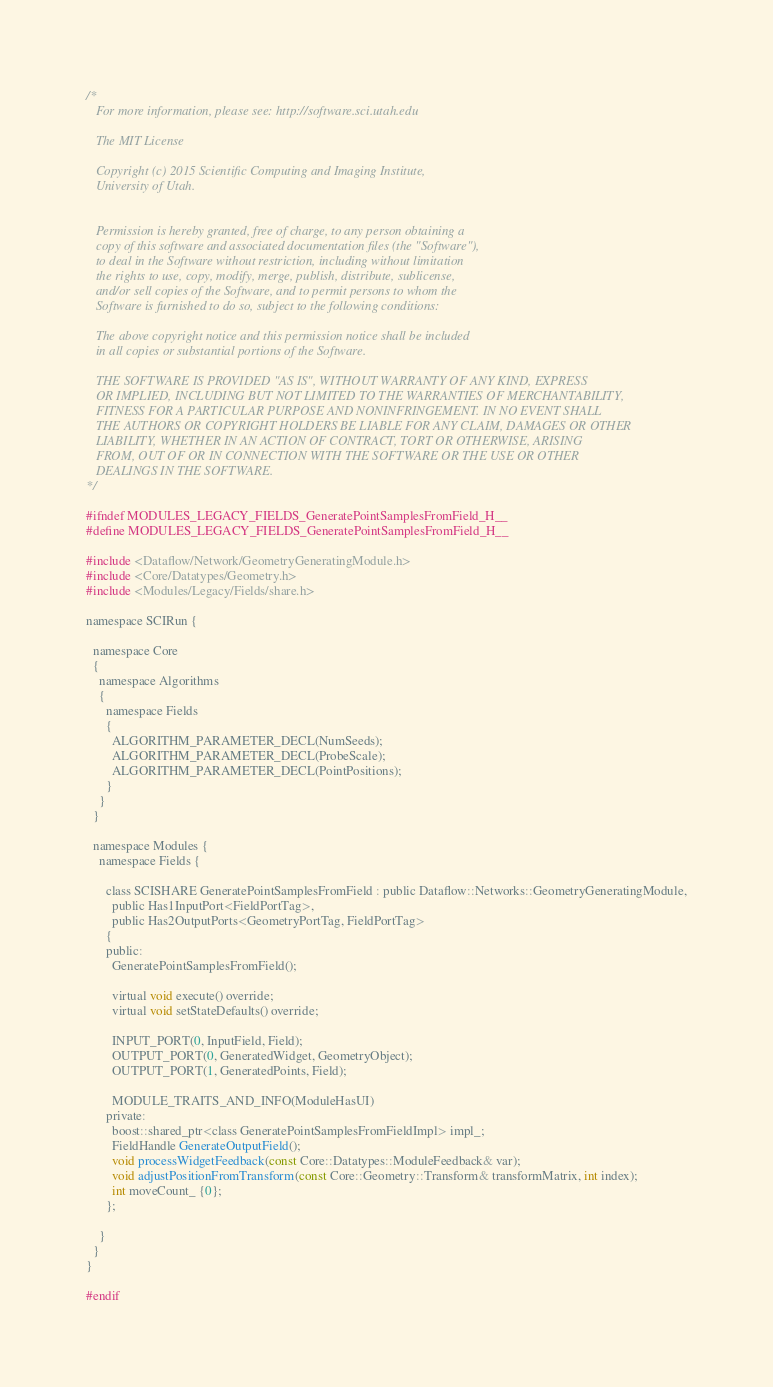Convert code to text. <code><loc_0><loc_0><loc_500><loc_500><_C_>/*
   For more information, please see: http://software.sci.utah.edu

   The MIT License

   Copyright (c) 2015 Scientific Computing and Imaging Institute,
   University of Utah.


   Permission is hereby granted, free of charge, to any person obtaining a
   copy of this software and associated documentation files (the "Software"),
   to deal in the Software without restriction, including without limitation
   the rights to use, copy, modify, merge, publish, distribute, sublicense,
   and/or sell copies of the Software, and to permit persons to whom the
   Software is furnished to do so, subject to the following conditions:

   The above copyright notice and this permission notice shall be included
   in all copies or substantial portions of the Software.

   THE SOFTWARE IS PROVIDED "AS IS", WITHOUT WARRANTY OF ANY KIND, EXPRESS
   OR IMPLIED, INCLUDING BUT NOT LIMITED TO THE WARRANTIES OF MERCHANTABILITY,
   FITNESS FOR A PARTICULAR PURPOSE AND NONINFRINGEMENT. IN NO EVENT SHALL
   THE AUTHORS OR COPYRIGHT HOLDERS BE LIABLE FOR ANY CLAIM, DAMAGES OR OTHER
   LIABILITY, WHETHER IN AN ACTION OF CONTRACT, TORT OR OTHERWISE, ARISING
   FROM, OUT OF OR IN CONNECTION WITH THE SOFTWARE OR THE USE OR OTHER
   DEALINGS IN THE SOFTWARE.
*/

#ifndef MODULES_LEGACY_FIELDS_GeneratePointSamplesFromField_H__
#define MODULES_LEGACY_FIELDS_GeneratePointSamplesFromField_H__

#include <Dataflow/Network/GeometryGeneratingModule.h>
#include <Core/Datatypes/Geometry.h>
#include <Modules/Legacy/Fields/share.h>

namespace SCIRun {

  namespace Core
  {
    namespace Algorithms
    {
      namespace Fields
      {
        ALGORITHM_PARAMETER_DECL(NumSeeds);
        ALGORITHM_PARAMETER_DECL(ProbeScale);
        ALGORITHM_PARAMETER_DECL(PointPositions);
      }
    }
  }

  namespace Modules {
    namespace Fields {

      class SCISHARE GeneratePointSamplesFromField : public Dataflow::Networks::GeometryGeneratingModule,
        public Has1InputPort<FieldPortTag>,
        public Has2OutputPorts<GeometryPortTag, FieldPortTag>
      {
      public:
        GeneratePointSamplesFromField();

        virtual void execute() override;
        virtual void setStateDefaults() override;

        INPUT_PORT(0, InputField, Field);
        OUTPUT_PORT(0, GeneratedWidget, GeometryObject);
        OUTPUT_PORT(1, GeneratedPoints, Field);

        MODULE_TRAITS_AND_INFO(ModuleHasUI)
      private:
        boost::shared_ptr<class GeneratePointSamplesFromFieldImpl> impl_;
        FieldHandle GenerateOutputField();
        void processWidgetFeedback(const Core::Datatypes::ModuleFeedback& var);
        void adjustPositionFromTransform(const Core::Geometry::Transform& transformMatrix, int index);
        int moveCount_ {0};
      };

    }
  }
}

#endif
</code> 